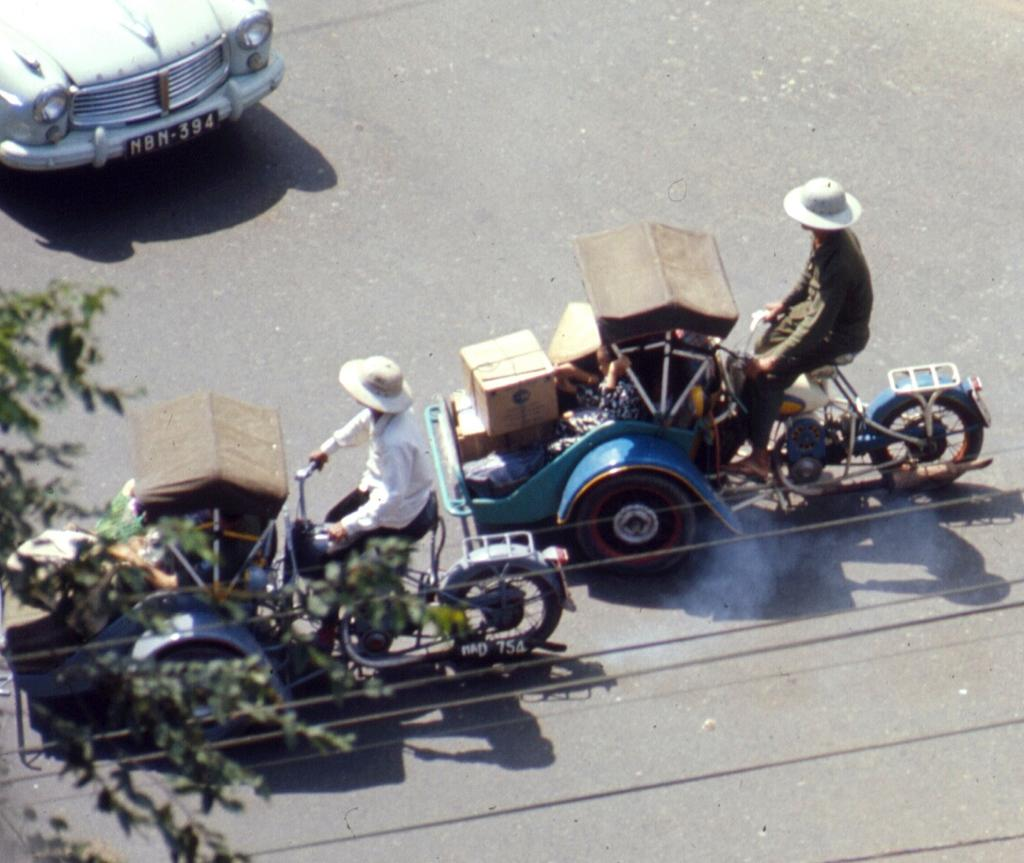What is the main subject of the image? The main subject of the image is a car. What other objects can be seen in the image? There is a tree and boxes visible in the image. How many people are riding vehicles in the image? There are two people riding vehicles in the image. What type of pump can be seen in the image? There is no pump present in the image. Is the person riding the vehicle related to the other person in the image? The provided facts do not mention any familial relationships between the people in the image, so we cannot determine if they are related, such as being brothers. --- 